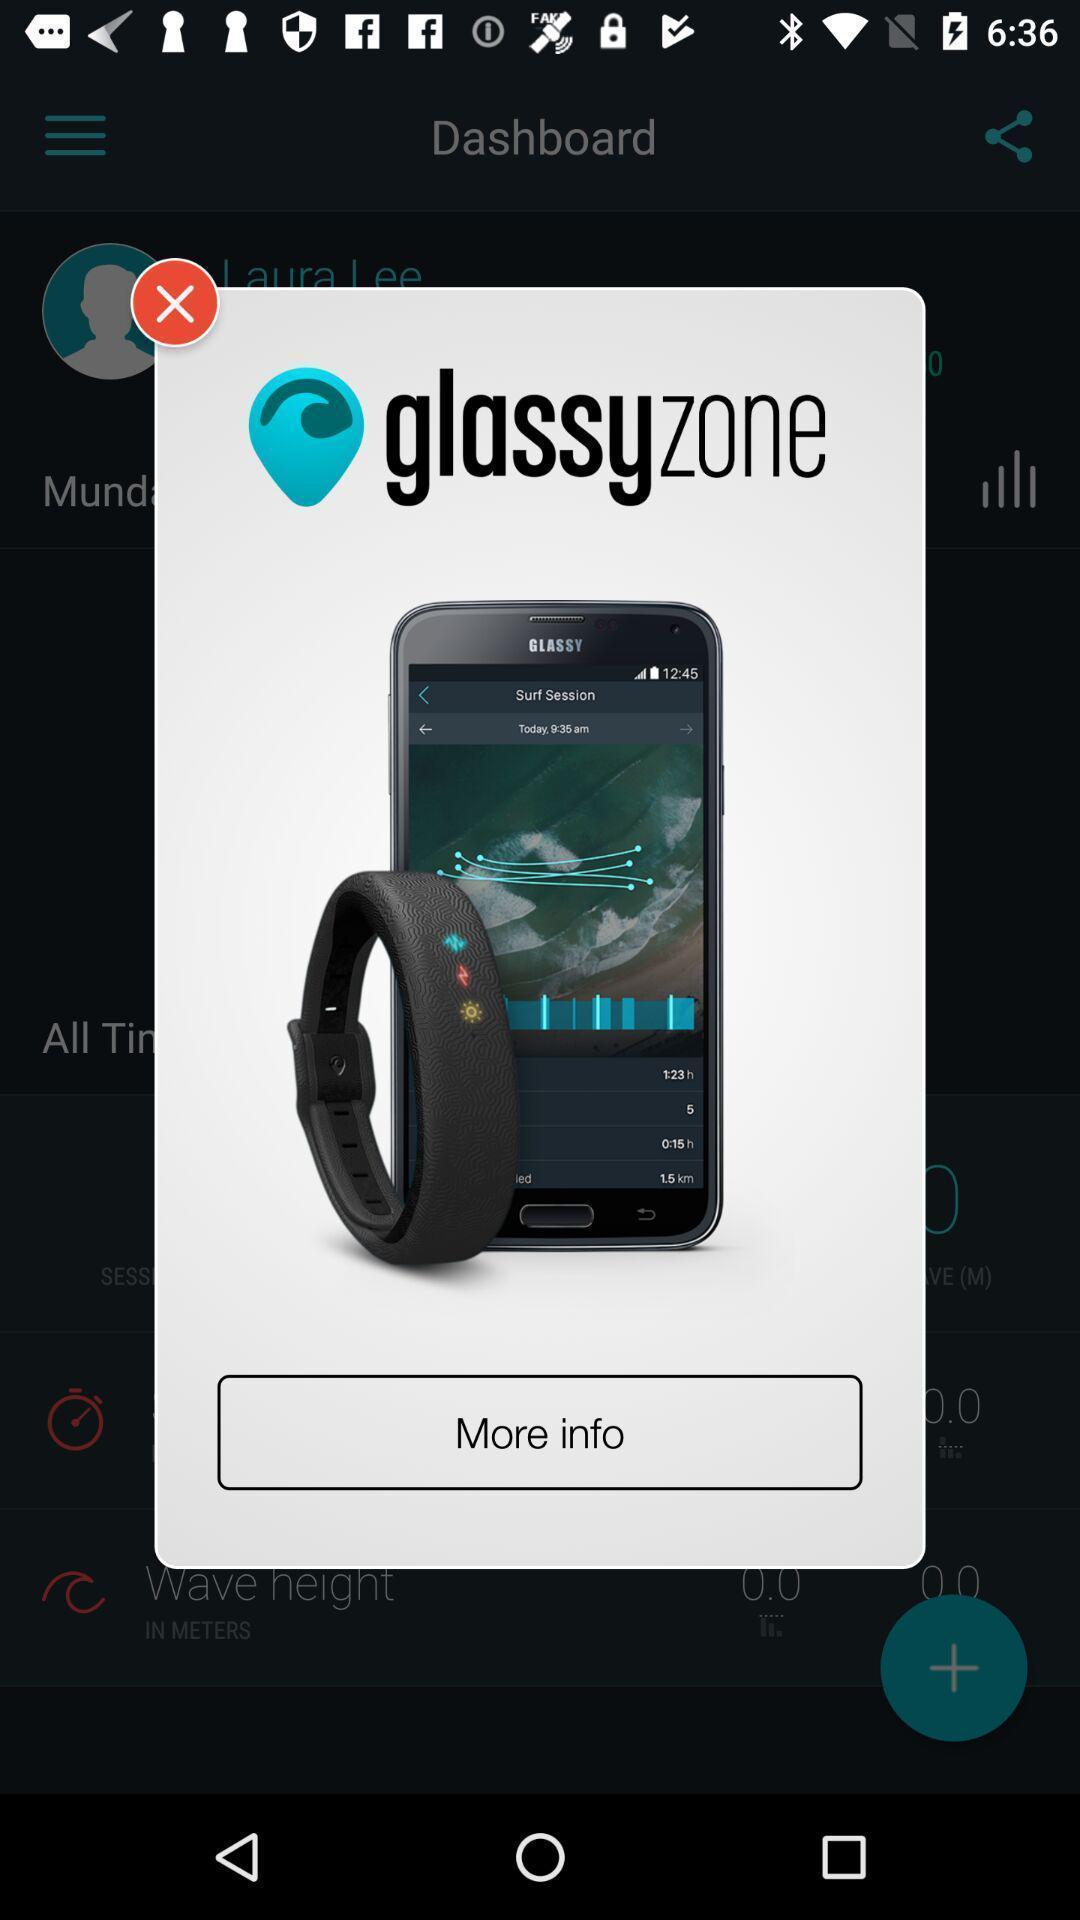Explain the elements present in this screenshot. Pop-up screen displaying product images and option to more information. 